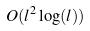<formula> <loc_0><loc_0><loc_500><loc_500>O ( l ^ { 2 } \log ( l ) )</formula> 